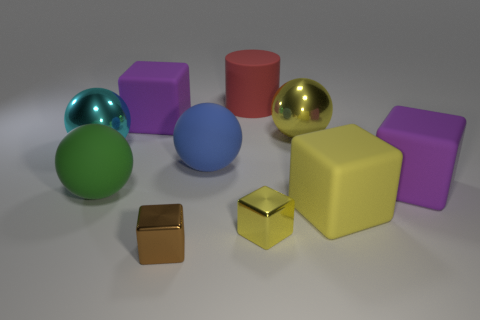Subtract all big green matte spheres. How many spheres are left? 3 Subtract all blue cylinders. How many yellow blocks are left? 2 Subtract 2 blocks. How many blocks are left? 3 Subtract all green balls. How many balls are left? 3 Subtract all cylinders. How many objects are left? 9 Subtract all yellow cubes. Subtract all brown spheres. How many cubes are left? 3 Subtract all big balls. Subtract all cyan metallic balls. How many objects are left? 5 Add 3 big cyan spheres. How many big cyan spheres are left? 4 Add 4 rubber objects. How many rubber objects exist? 10 Subtract 1 brown cubes. How many objects are left? 9 